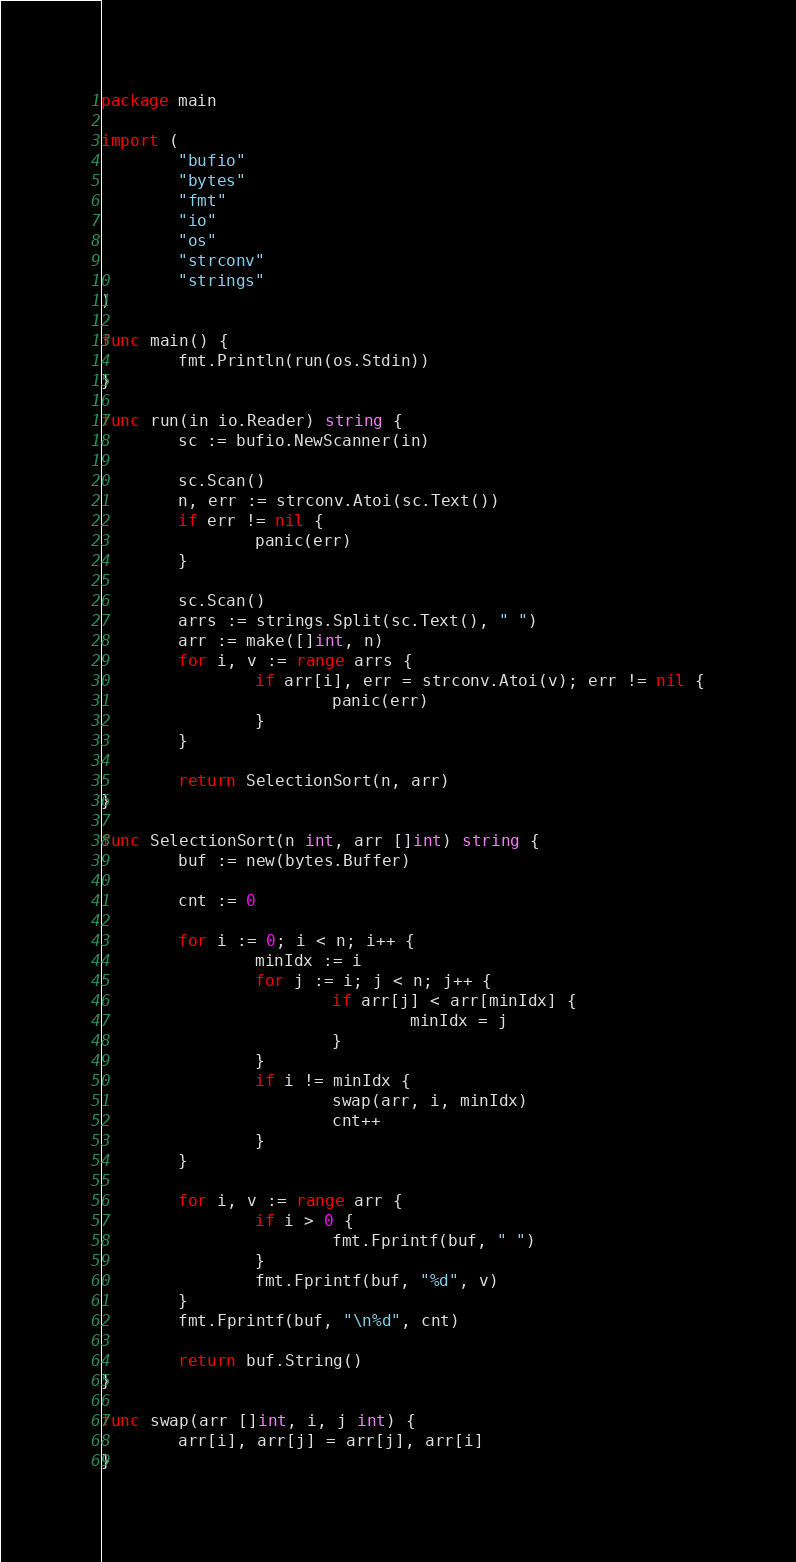Convert code to text. <code><loc_0><loc_0><loc_500><loc_500><_Go_>package main

import (
        "bufio"
        "bytes"
        "fmt"
        "io"
        "os"
        "strconv"
        "strings"
)

func main() {
        fmt.Println(run(os.Stdin))
}

func run(in io.Reader) string {
        sc := bufio.NewScanner(in)

        sc.Scan()
        n, err := strconv.Atoi(sc.Text())
        if err != nil {
                panic(err)
        }

        sc.Scan()
        arrs := strings.Split(sc.Text(), " ")
        arr := make([]int, n)
        for i, v := range arrs {
                if arr[i], err = strconv.Atoi(v); err != nil {
                        panic(err)
                }
        }

        return SelectionSort(n, arr)
}

func SelectionSort(n int, arr []int) string {
        buf := new(bytes.Buffer)

        cnt := 0

        for i := 0; i < n; i++ {
                minIdx := i
                for j := i; j < n; j++ {
                        if arr[j] < arr[minIdx] {
                                minIdx = j
                        }
                }
                if i != minIdx {
                        swap(arr, i, minIdx)
                        cnt++
                }
        }

        for i, v := range arr {
                if i > 0 {
                        fmt.Fprintf(buf, " ")
                }
                fmt.Fprintf(buf, "%d", v)
        }
        fmt.Fprintf(buf, "\n%d", cnt)

        return buf.String()
}

func swap(arr []int, i, j int) {
        arr[i], arr[j] = arr[j], arr[i]
}

</code> 